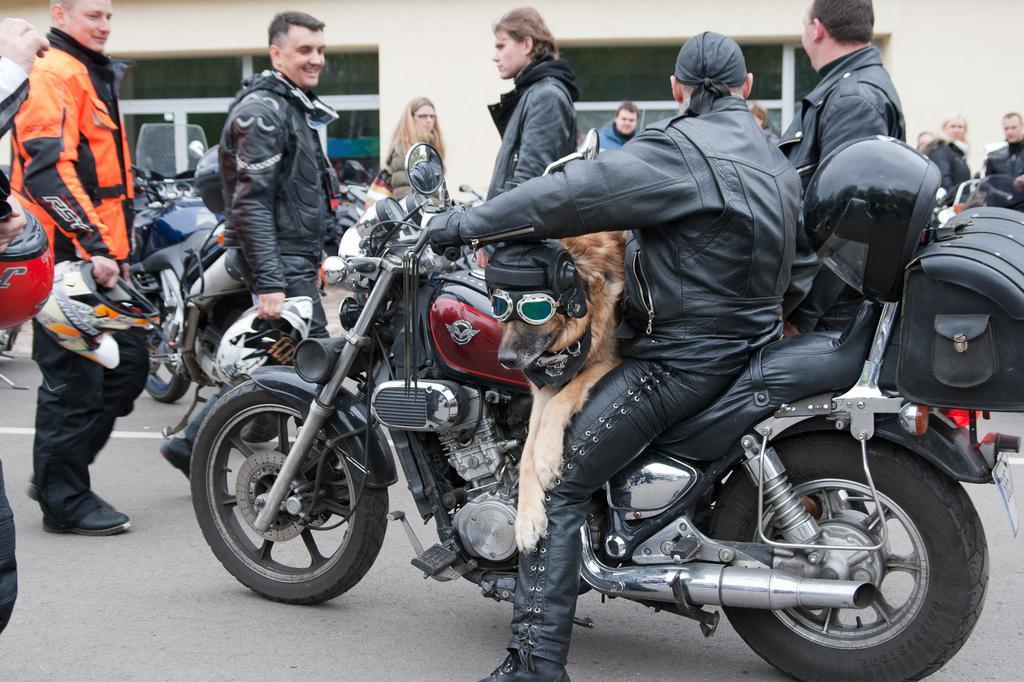Could you give a brief overview of what you see in this image? This is a picture consist of road and there are the number of people standing on the road. In front of the image a person sit on the bi cycle , and there is a dog sit on the bi cycle and back side of the bi cycle there is a helmet kept on that , and on the back ground there is a building visible. 